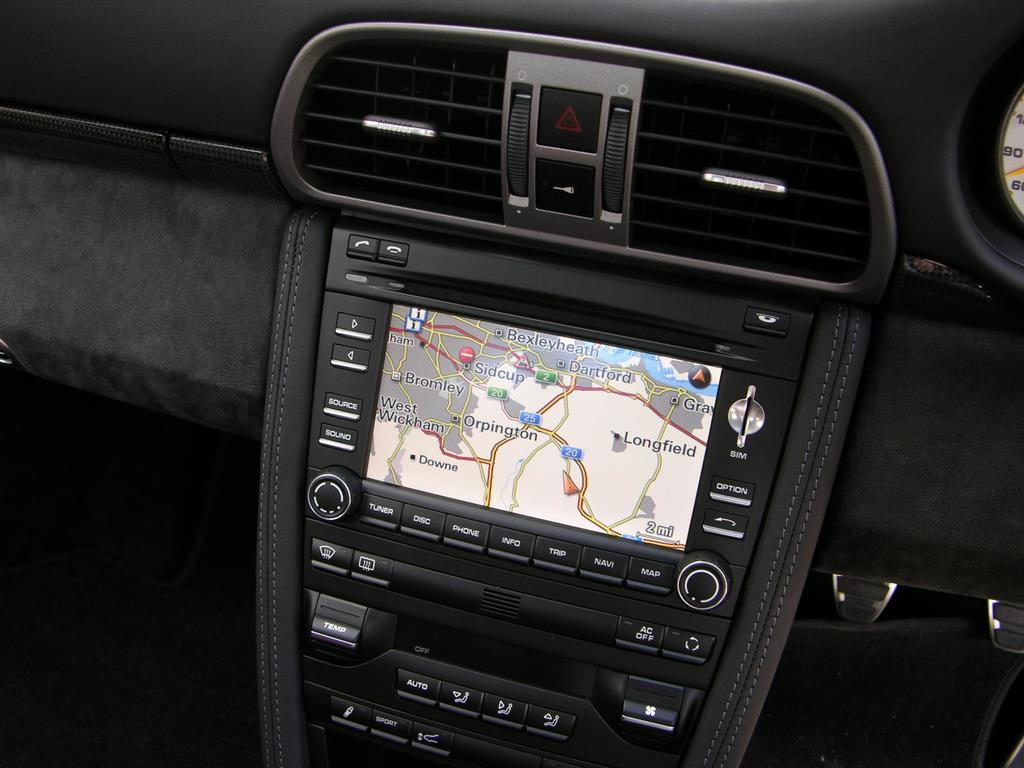What is the main feature of the image? The main feature of the image is a dashboard. What can be found on the dashboard? There is an AC ventilation and a screen with keys on the dashboard. What type of wilderness can be seen through the windshield in the image? There is no windshield or wilderness visible in the image; it only shows a dashboard with AC ventilation and a screen with keys. 